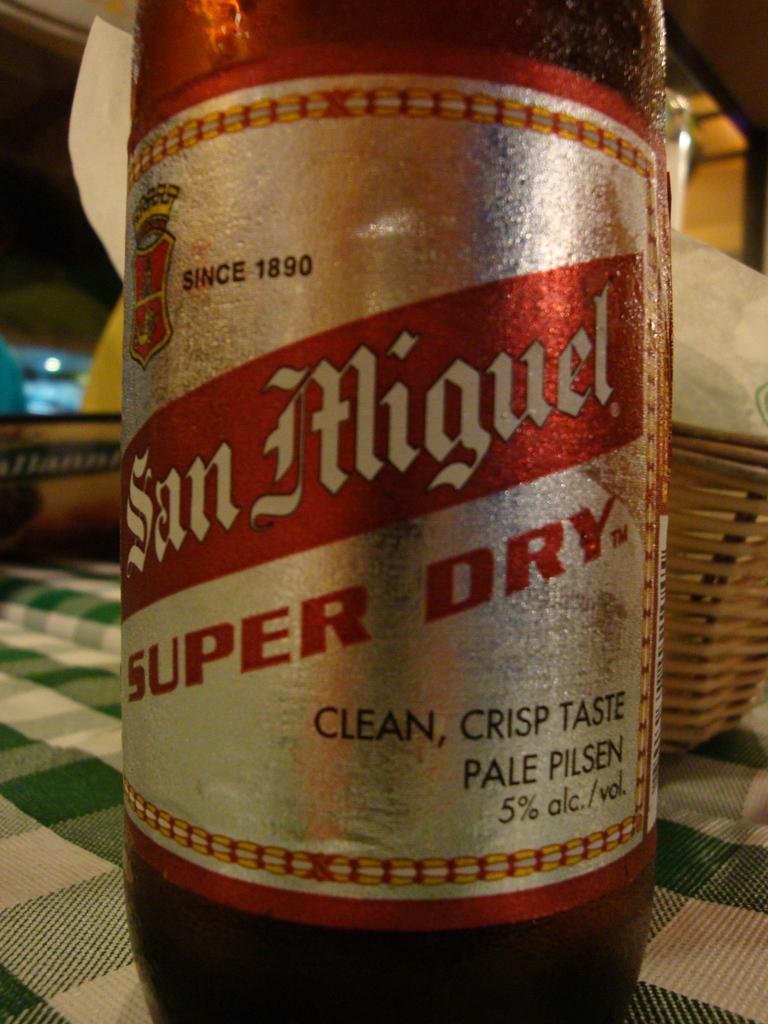What kind of taste does this have?
Keep it short and to the point. Clean, crisp. What year was san miguel first made?
Provide a short and direct response. 1890. 